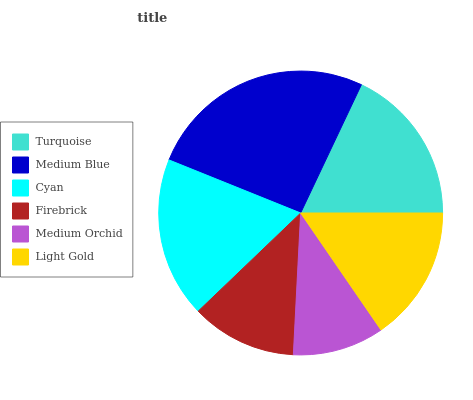Is Medium Orchid the minimum?
Answer yes or no. Yes. Is Medium Blue the maximum?
Answer yes or no. Yes. Is Cyan the minimum?
Answer yes or no. No. Is Cyan the maximum?
Answer yes or no. No. Is Medium Blue greater than Cyan?
Answer yes or no. Yes. Is Cyan less than Medium Blue?
Answer yes or no. Yes. Is Cyan greater than Medium Blue?
Answer yes or no. No. Is Medium Blue less than Cyan?
Answer yes or no. No. Is Turquoise the high median?
Answer yes or no. Yes. Is Light Gold the low median?
Answer yes or no. Yes. Is Light Gold the high median?
Answer yes or no. No. Is Turquoise the low median?
Answer yes or no. No. 